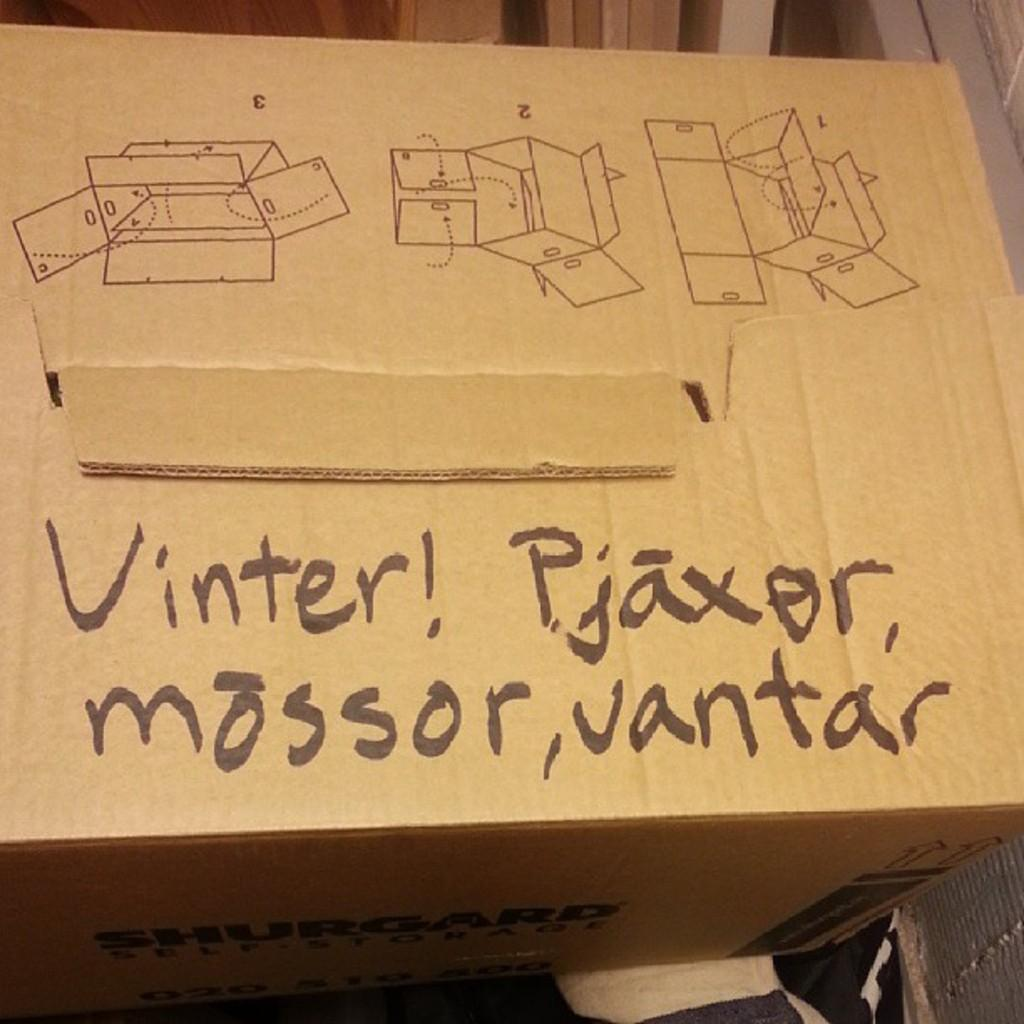<image>
Relay a brief, clear account of the picture shown. A cardboard box has the words "Vinter! Pjaxor, Mossor, Vantar" written on the top. 